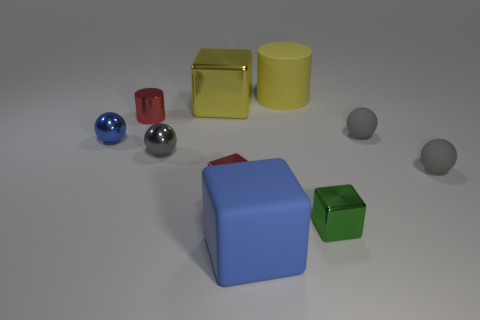Subtract all gray balls. How many were subtracted if there are1gray balls left? 2 Subtract all small blue metal balls. How many balls are left? 3 Subtract 0 green spheres. How many objects are left? 10 Subtract all blocks. How many objects are left? 6 Subtract 4 blocks. How many blocks are left? 0 Subtract all brown spheres. Subtract all purple cubes. How many spheres are left? 4 Subtract all gray balls. How many yellow blocks are left? 1 Subtract all small brown matte blocks. Subtract all cylinders. How many objects are left? 8 Add 9 tiny green objects. How many tiny green objects are left? 10 Add 2 big green cylinders. How many big green cylinders exist? 2 